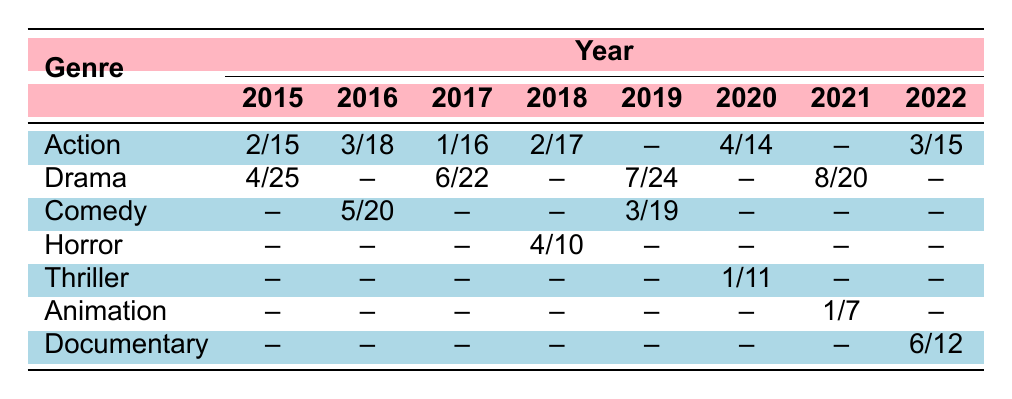What is the total number of films directed by female directors in the Action genre in 2015? In 2015, there were 15 total films in the Action genre, and the number of female directors was 2. The answer is simply the number of films, which is stated as 15.
Answer: 15 How many female directors were there in Comedy films in 2016? According to the table, in 2016, there were 5 female directors in the Comedy genre. This information is directly provided in the table.
Answer: 5 Did the number of female directors in Drama films increase from 2017 to 2021? In 2017, there were 6 female directors in Drama films, while in 2021, there were 8. Since 8 is greater than 6, it indicates an increase.
Answer: Yes What year had the least number of female directors in Action films, and how many were there? The years for Action films show 2 in 2015, 3 in 2016, 1 in 2017, 2 in 2018, 4 in 2020, 3 in 2022, and 2 in 2023. The least number is 1 in 2017.
Answer: 2017, 1 What is the percentage of female directors in Action films for the year 2020? For Action films in 2020, there were 4 female directors out of a total of 14 films. The percentage is calculated as (4/14) * 100 = 28.57%. Therefore, we round this off to two decimal places.
Answer: 28.57% How do the female director counts in Drama films compare between 2019 and 2022? In 2019, there were 7 female directors in Drama, while in 2022, there were 0, as indicated by the table. Since 7 is greater than 0, this shows that there were more female directors in 2019 compared to 2022.
Answer: 2019 had more directors What is the average total number of films across all genres in 2019? The total number of films across the genres in 2019 was 24 (Drama) + 19 (Comedy) = 43. To find the average, we consider the number of genres, which is 2. Therefore, the average is 43 / 2 = 21.5.
Answer: 21.5 Which genre had the highest number of female directors in 2021? The table indicates that in 2021, the Drama genre had 8 female directors while Animation had only 1. Therefore, Drama is the genre with the highest count.
Answer: Drama Which year saw a decline in female directors for Action films compared to the previous year? Examining the information, 2017 had only 1 female director in Action compared to 3 in 2016, indicating a decline.
Answer: 2017 